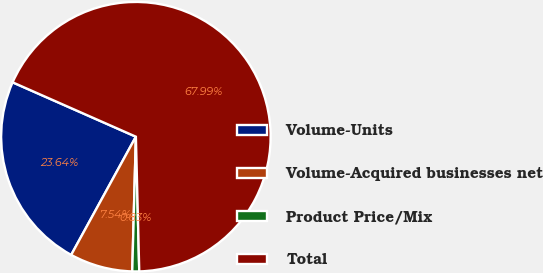Convert chart. <chart><loc_0><loc_0><loc_500><loc_500><pie_chart><fcel>Volume-Units<fcel>Volume-Acquired businesses net<fcel>Product Price/Mix<fcel>Total<nl><fcel>23.64%<fcel>7.54%<fcel>0.83%<fcel>67.99%<nl></chart> 